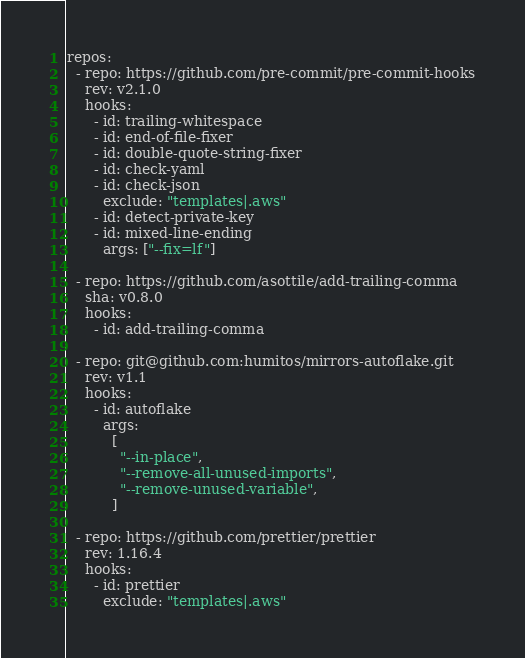Convert code to text. <code><loc_0><loc_0><loc_500><loc_500><_YAML_>repos:
  - repo: https://github.com/pre-commit/pre-commit-hooks
    rev: v2.1.0
    hooks:
      - id: trailing-whitespace
      - id: end-of-file-fixer
      - id: double-quote-string-fixer
      - id: check-yaml
      - id: check-json
        exclude: "templates|.aws"
      - id: detect-private-key
      - id: mixed-line-ending
        args: ["--fix=lf"]

  - repo: https://github.com/asottile/add-trailing-comma
    sha: v0.8.0
    hooks:
      - id: add-trailing-comma

  - repo: git@github.com:humitos/mirrors-autoflake.git
    rev: v1.1
    hooks:
      - id: autoflake
        args:
          [
            "--in-place",
            "--remove-all-unused-imports",
            "--remove-unused-variable",
          ]

  - repo: https://github.com/prettier/prettier
    rev: 1.16.4
    hooks:
      - id: prettier
        exclude: "templates|.aws"
</code> 